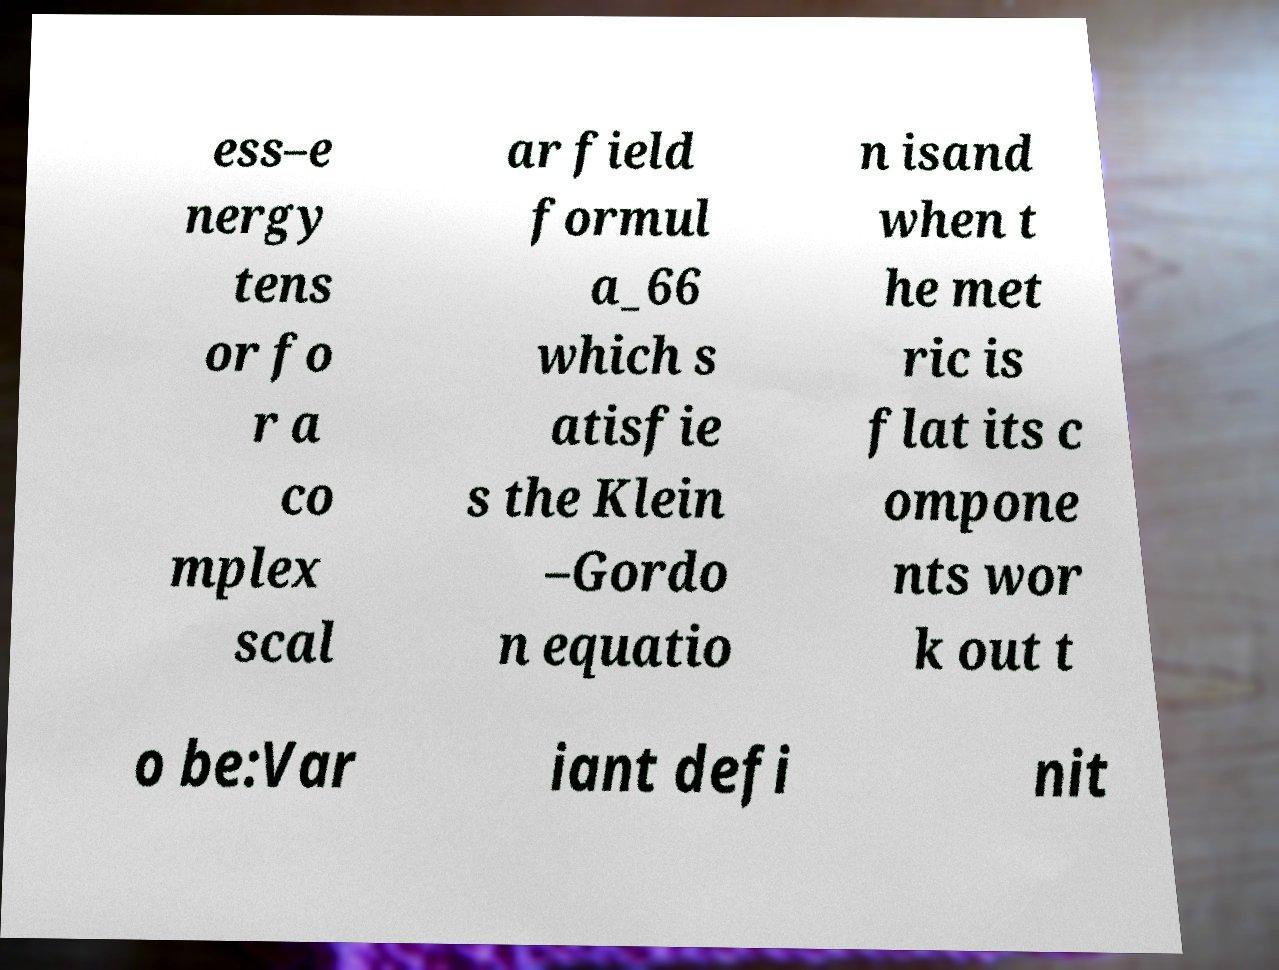Could you extract and type out the text from this image? ess–e nergy tens or fo r a co mplex scal ar field formul a_66 which s atisfie s the Klein –Gordo n equatio n isand when t he met ric is flat its c ompone nts wor k out t o be:Var iant defi nit 